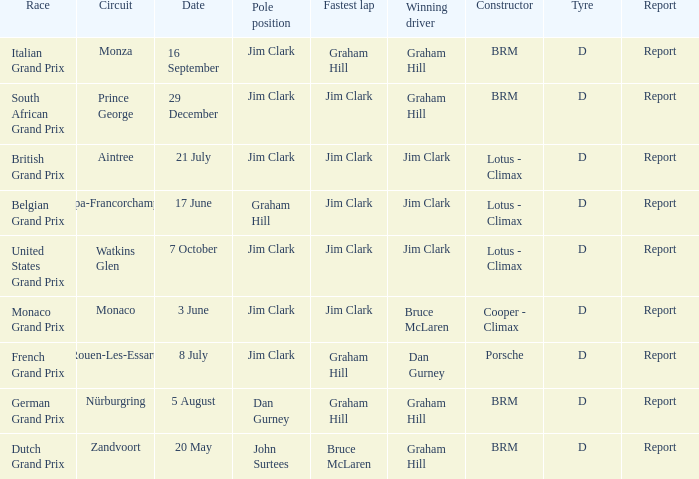What is the constructor at the United States Grand Prix? Lotus - Climax. 